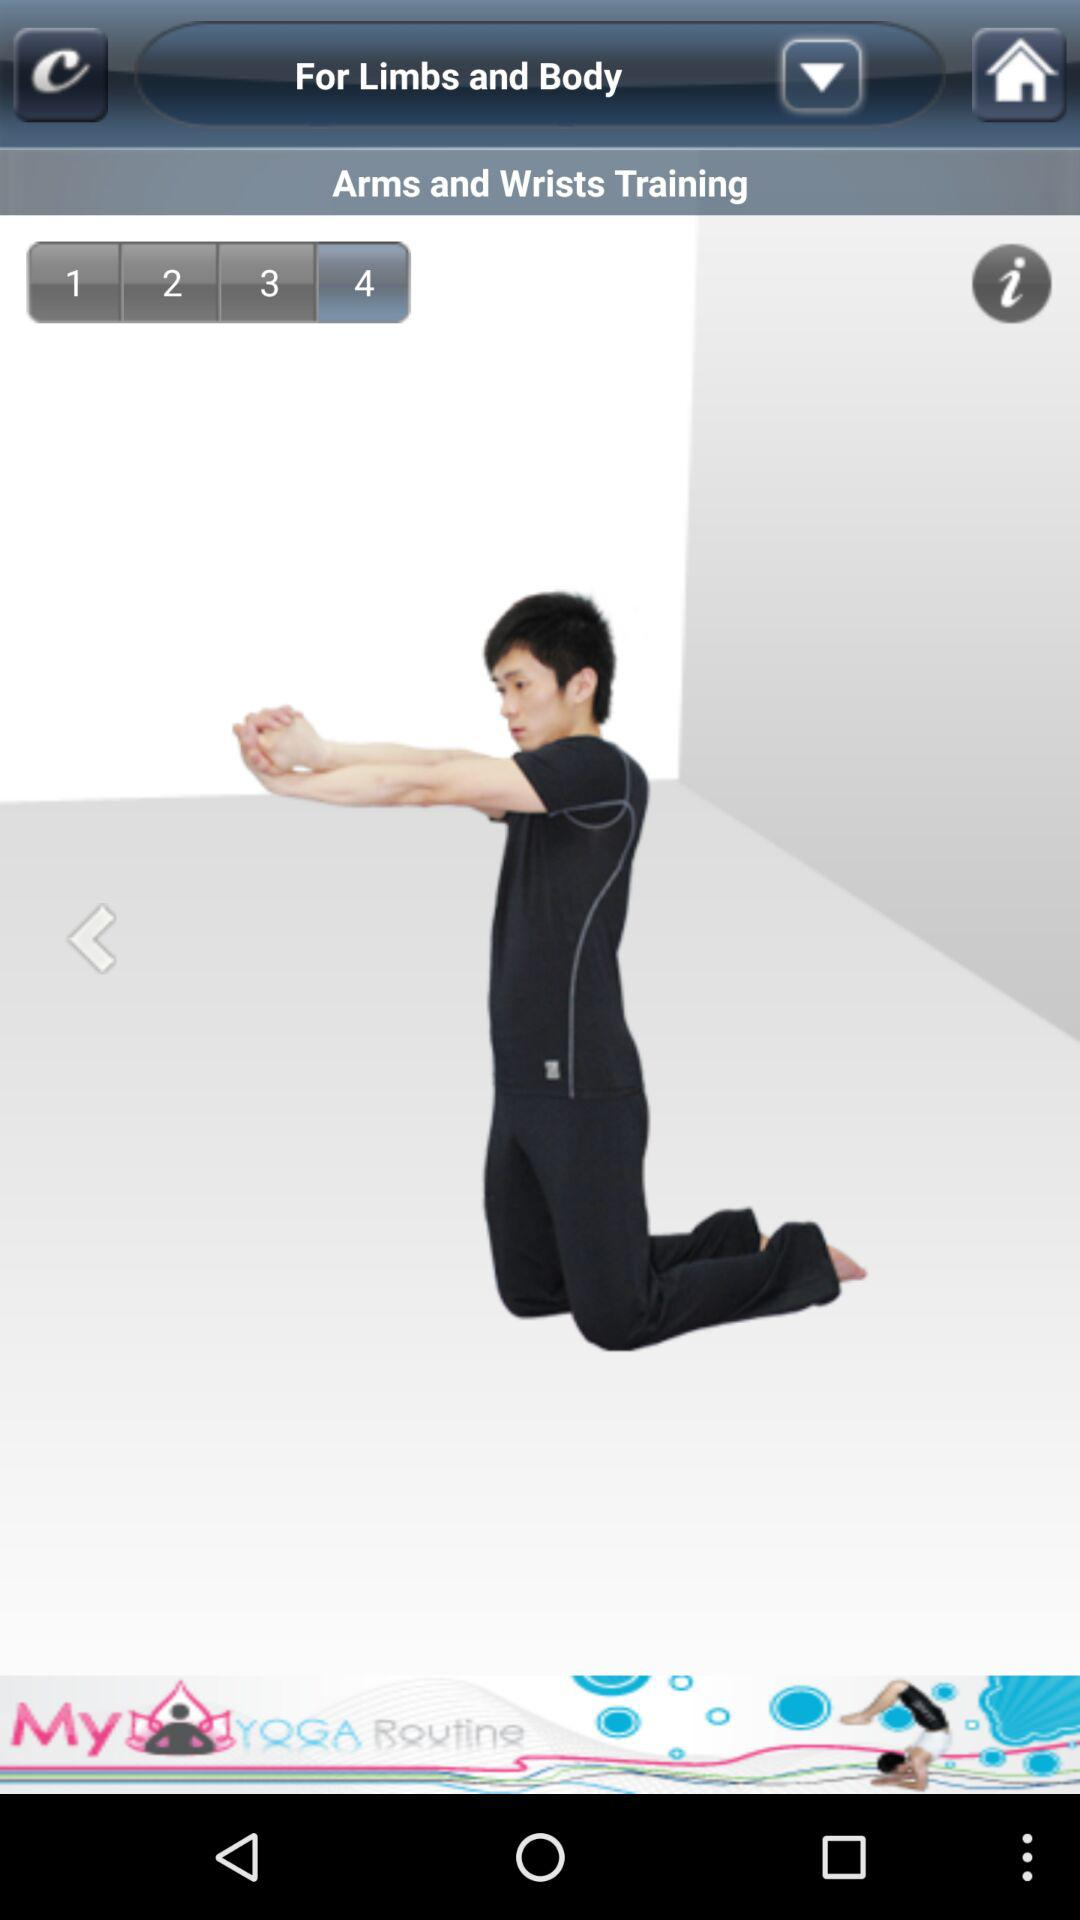How many steps in total are there? There are 4 steps in total. 